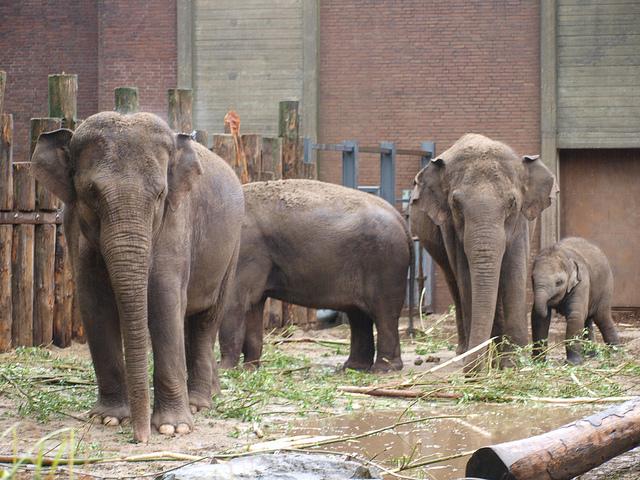How many elephants are there?
Write a very short answer. 4. Which of these elephants is the youngest?
Answer briefly. Back one. Are the elephants bathing in a lake?
Concise answer only. No. 